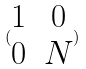Convert formula to latex. <formula><loc_0><loc_0><loc_500><loc_500>( \begin{matrix} 1 & 0 \\ 0 & N \end{matrix} )</formula> 